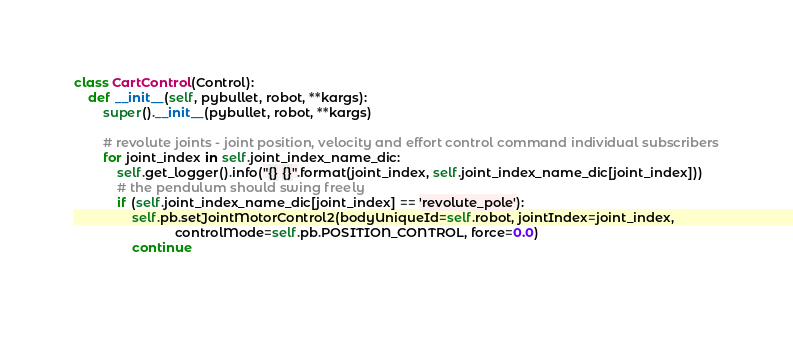<code> <loc_0><loc_0><loc_500><loc_500><_Python_>

class CartControl(Control):
    def __init__(self, pybullet, robot, **kargs):
        super().__init__(pybullet, robot, **kargs)
        
        # revolute joints - joint position, velocity and effort control command individual subscribers
        for joint_index in self.joint_index_name_dic:
            self.get_logger().info("{} {}".format(joint_index, self.joint_index_name_dic[joint_index]))
            # the pendulum should swing freely
            if (self.joint_index_name_dic[joint_index] == 'revolute_pole'):
                self.pb.setJointMotorControl2(bodyUniqueId=self.robot, jointIndex=joint_index,
                            controlMode=self.pb.POSITION_CONTROL, force=0.0)
                continue
            
</code> 